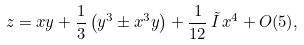Convert formula to latex. <formula><loc_0><loc_0><loc_500><loc_500>z = x y + \frac { 1 } { 3 } \left ( y ^ { 3 } \pm x ^ { 3 } y \right ) + \frac { 1 } { 1 2 } \, \tilde { I } \, x ^ { 4 } + O ( 5 ) ,</formula> 